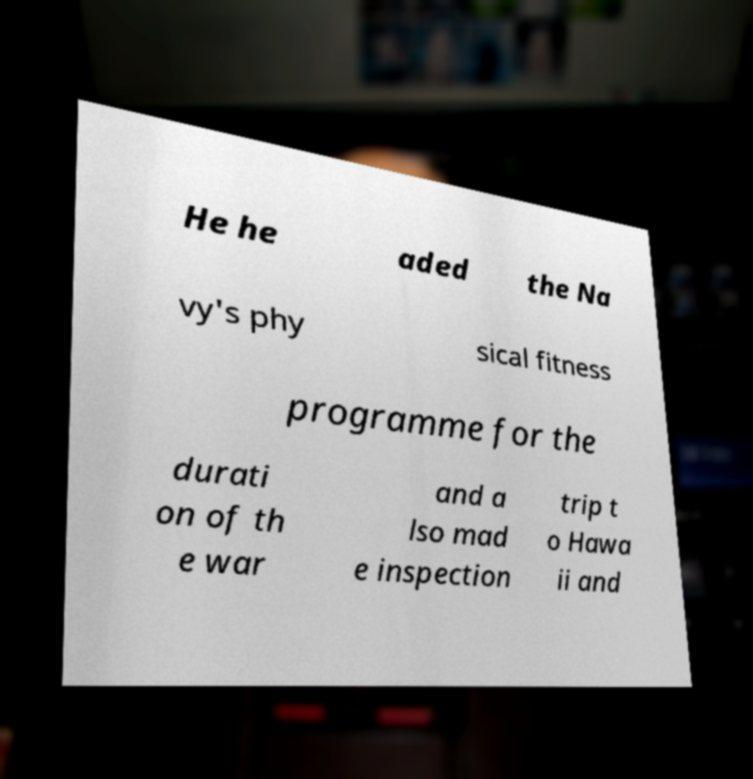Can you accurately transcribe the text from the provided image for me? He he aded the Na vy's phy sical fitness programme for the durati on of th e war and a lso mad e inspection trip t o Hawa ii and 